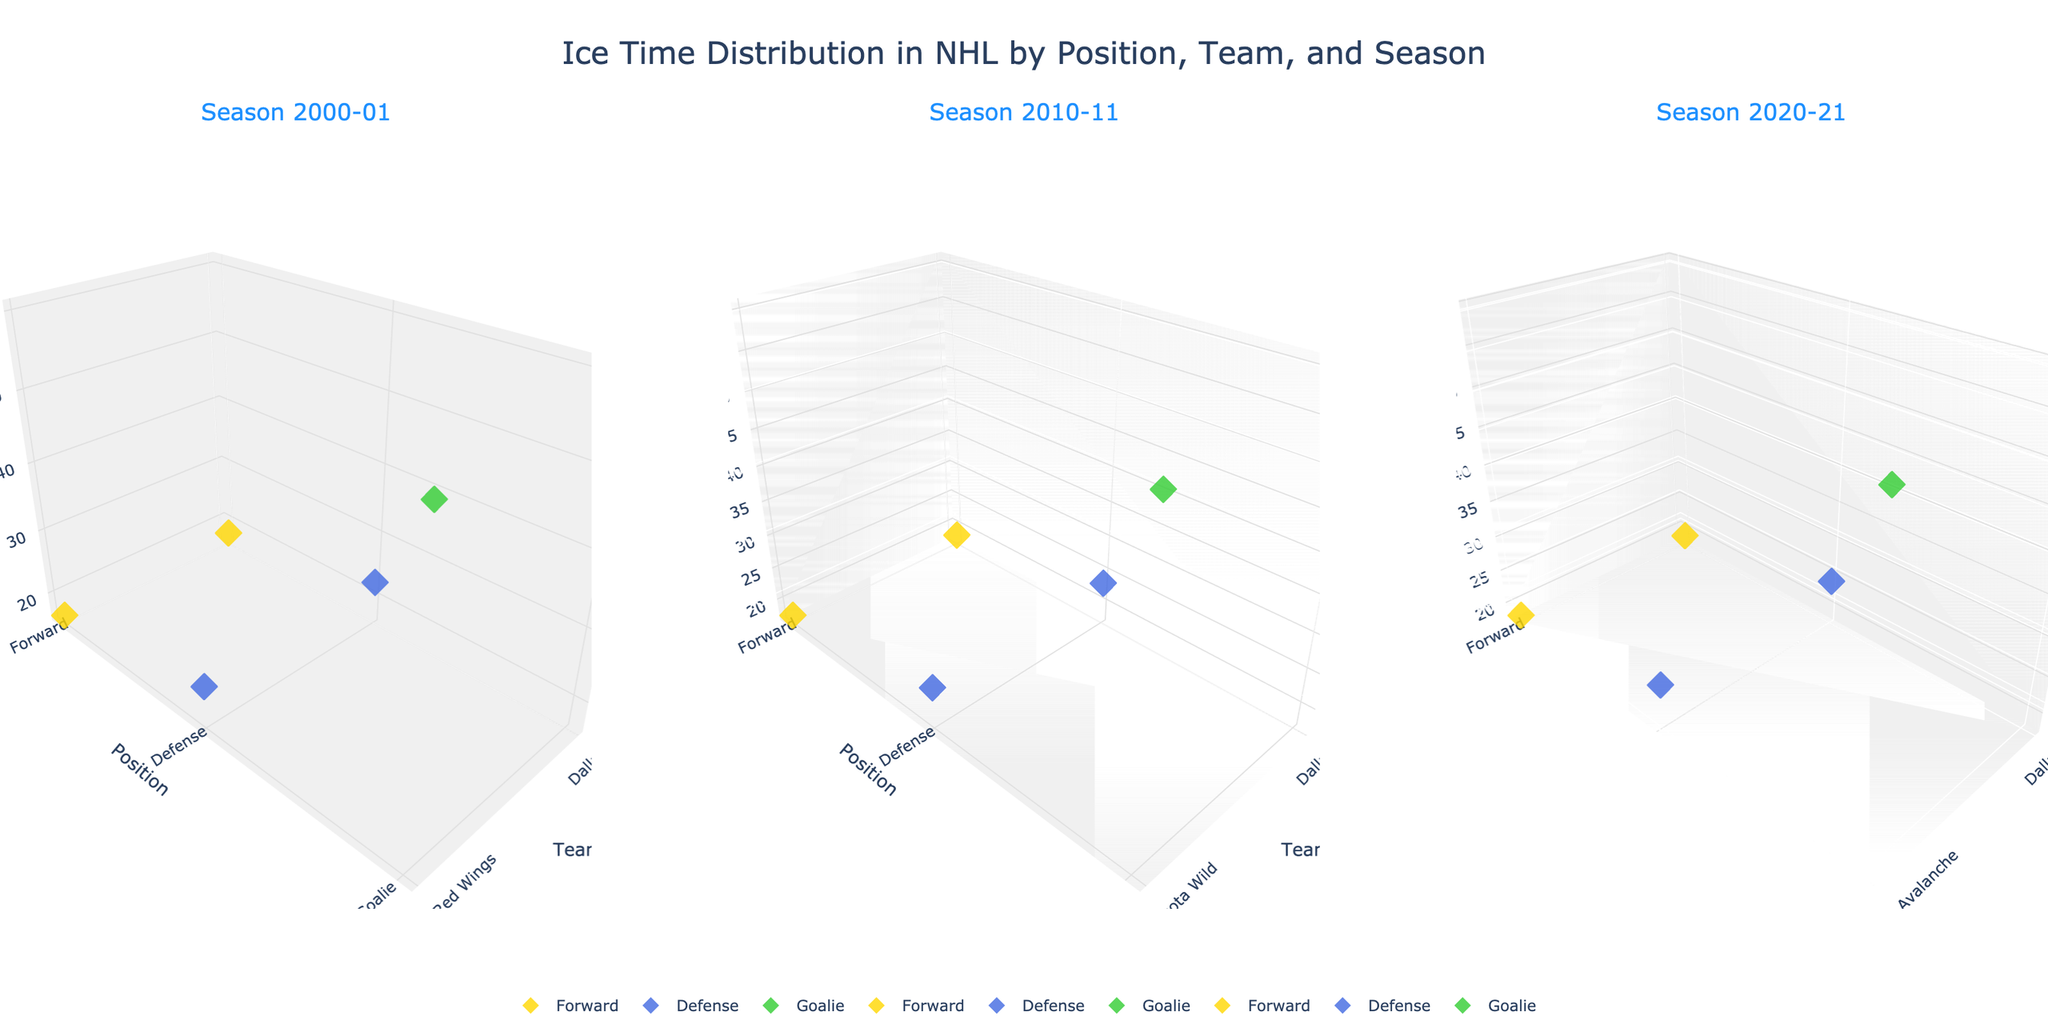What are the three seasons shown in the figure? The figure consists of three subplots, each corresponding to a different season shown on the titles of each subplot. The titles list the seasons as 2000-01, 2010-11, and 2020-21.
Answer: 2000-01, 2010-11, 2020-21 Which team has the highest average ice time for the Goalie position across all shown seasons? To find this, look at the z-axis values for Goalie positions in all subplots. The Goalie position data points for Dallas Stars are always at 60 minutes, which is the highest indicated value.
Answer: Dallas Stars How does the average ice time for Defense positions compare between the Dallas Stars and the Colorado Avalanche in the 2020-21 season? Compare the z-axis values of the Defense positions for Dallas Stars and Colorado Avalanche. The Dallas Stars Defense has an average ice time of 23.8 minutes, while the Colorado Avalanche Defense has 23.5 minutes.
Answer: Dallas Stars has 0.3 more minutes What is the color used to represent the Forward position, and is it consistent across all seasons? The Forward position is represented by a yellow color (gold). This is consistently used in all the subplots.
Answer: Yes, yellow Which positional group has the smallest range in average ice time across all teams and seasons? Examine the spread of z-axis values for Forward, Defense, and Goalie positions in each subplot. Forward and Defense have ranges from approximately 16.8 to 23.8 minutes, while Goalies range from 58.5 to 60.0 minutes. Goalie has the smallest range.
Answer: Goalie What is the trend in average ice time for Forwards from 2000-01 to 2020-21 for the Dallas Stars? Check the z-values across different subplots for Forwards. In 2000-01, it's 17.5 minutes; in 2010-11, it's 18.2 minutes; and in 2020-21, it's 18.7 minutes, indicating an increasing trend.
Answer: Increasing trend Which season shows the least variation in average ice time for Defense positions across all teams? Compare the spread of z-values for Defense positions in each season's subplot. 2020-21 season has closely clustered values of 23.8 and 23.5 minutes.
Answer: 2020-21 How does Mike Modano's era (2000-01 with Dallas Stars) compare to the 2020-21 season in terms of average ice time for Forwards? Compare the average ice times for Forwards in the Dallas Stars for the 2000-01 and 2020-21 seasons. The values are 17.5 minutes in 2000-01 and 18.7 minutes in 2020-21.
Answer: 2020-21 is higher by 1.2 minutes 